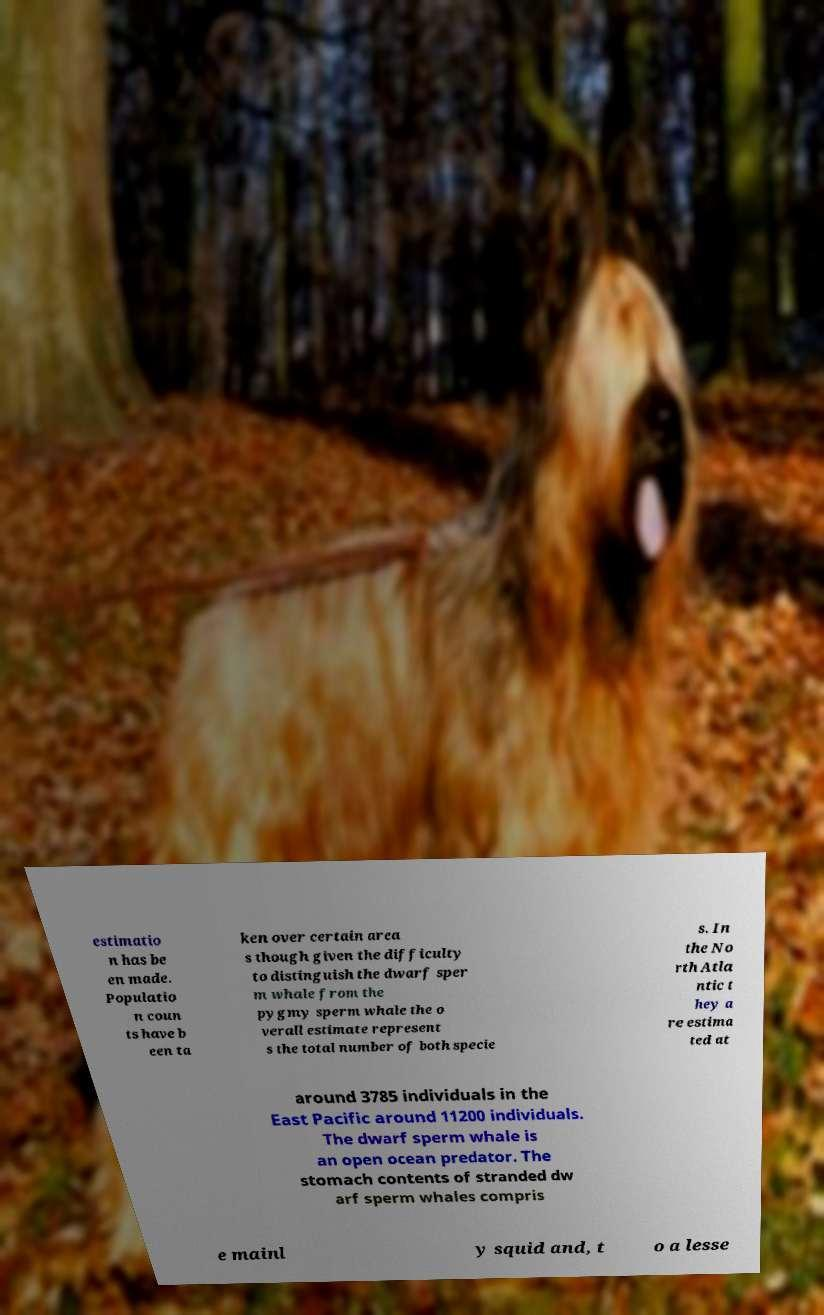Could you assist in decoding the text presented in this image and type it out clearly? estimatio n has be en made. Populatio n coun ts have b een ta ken over certain area s though given the difficulty to distinguish the dwarf sper m whale from the pygmy sperm whale the o verall estimate represent s the total number of both specie s. In the No rth Atla ntic t hey a re estima ted at around 3785 individuals in the East Pacific around 11200 individuals. The dwarf sperm whale is an open ocean predator. The stomach contents of stranded dw arf sperm whales compris e mainl y squid and, t o a lesse 